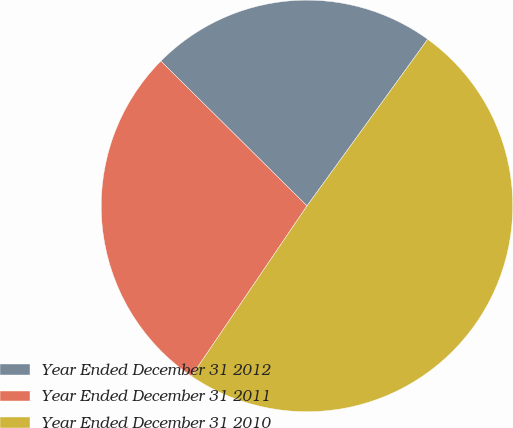Convert chart to OTSL. <chart><loc_0><loc_0><loc_500><loc_500><pie_chart><fcel>Year Ended December 31 2012<fcel>Year Ended December 31 2011<fcel>Year Ended December 31 2010<nl><fcel>22.55%<fcel>27.94%<fcel>49.51%<nl></chart> 